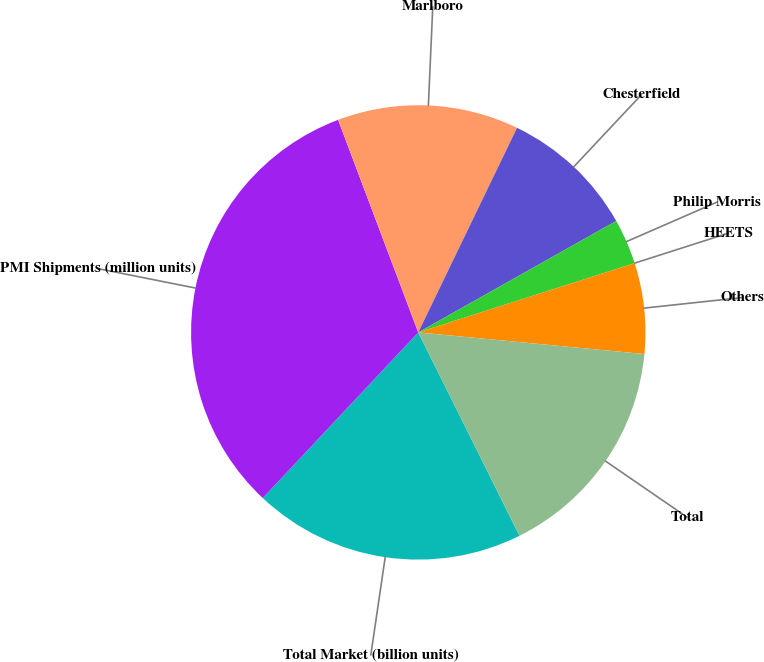<chart> <loc_0><loc_0><loc_500><loc_500><pie_chart><fcel>Total Market (billion units)<fcel>PMI Shipments (million units)<fcel>Marlboro<fcel>Chesterfield<fcel>Philip Morris<fcel>HEETS<fcel>Others<fcel>Total<nl><fcel>19.35%<fcel>32.26%<fcel>12.9%<fcel>9.68%<fcel>3.23%<fcel>0.0%<fcel>6.45%<fcel>16.13%<nl></chart> 